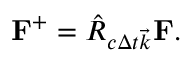<formula> <loc_0><loc_0><loc_500><loc_500>F ^ { + } = \hat { R } _ { c \Delta t \vec { k } } F .</formula> 